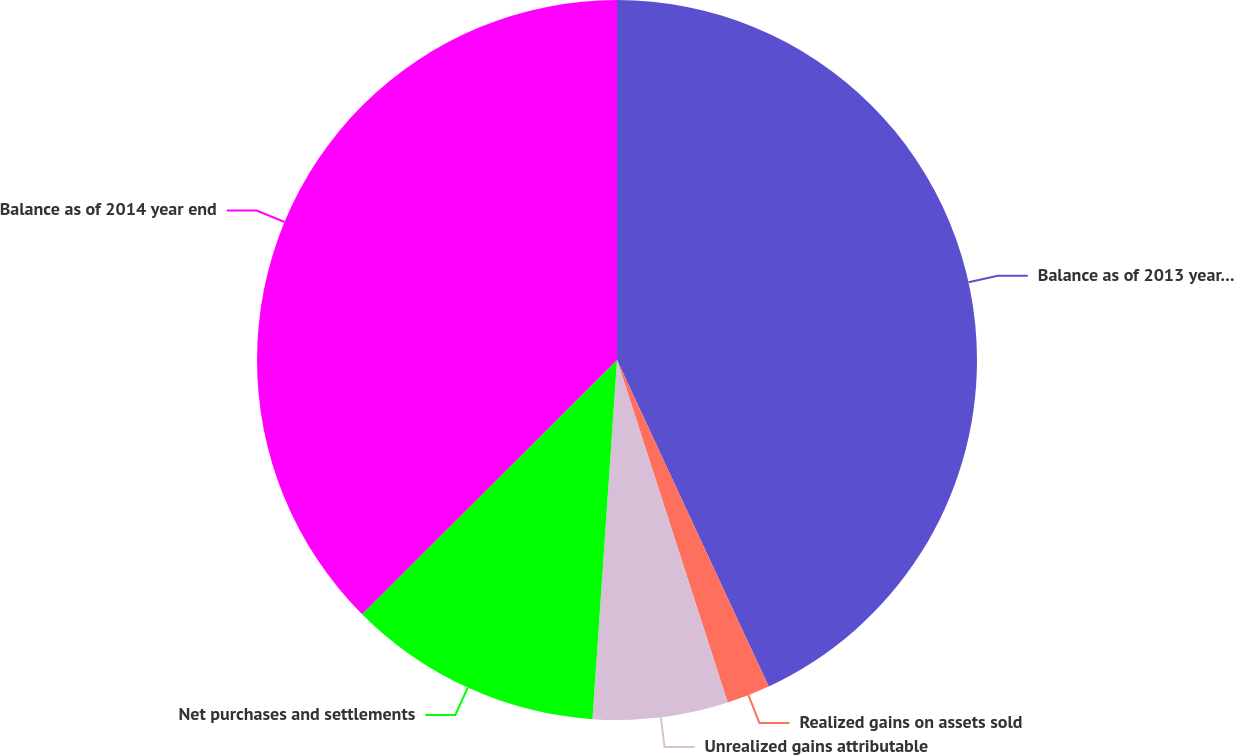Convert chart to OTSL. <chart><loc_0><loc_0><loc_500><loc_500><pie_chart><fcel>Balance as of 2013 year end<fcel>Realized gains on assets sold<fcel>Unrealized gains attributable<fcel>Net purchases and settlements<fcel>Balance as of 2014 year end<nl><fcel>43.08%<fcel>1.95%<fcel>6.06%<fcel>11.44%<fcel>37.48%<nl></chart> 